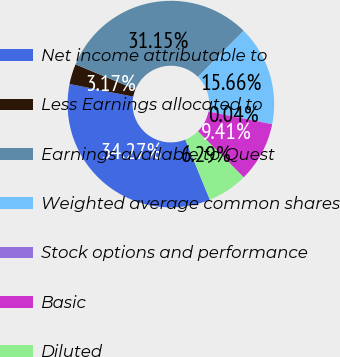<chart> <loc_0><loc_0><loc_500><loc_500><pie_chart><fcel>Net income attributable to<fcel>Less Earnings allocated to<fcel>Earnings available to Quest<fcel>Weighted average common shares<fcel>Stock options and performance<fcel>Basic<fcel>Diluted<nl><fcel>34.27%<fcel>3.17%<fcel>31.15%<fcel>15.66%<fcel>0.04%<fcel>9.41%<fcel>6.29%<nl></chart> 